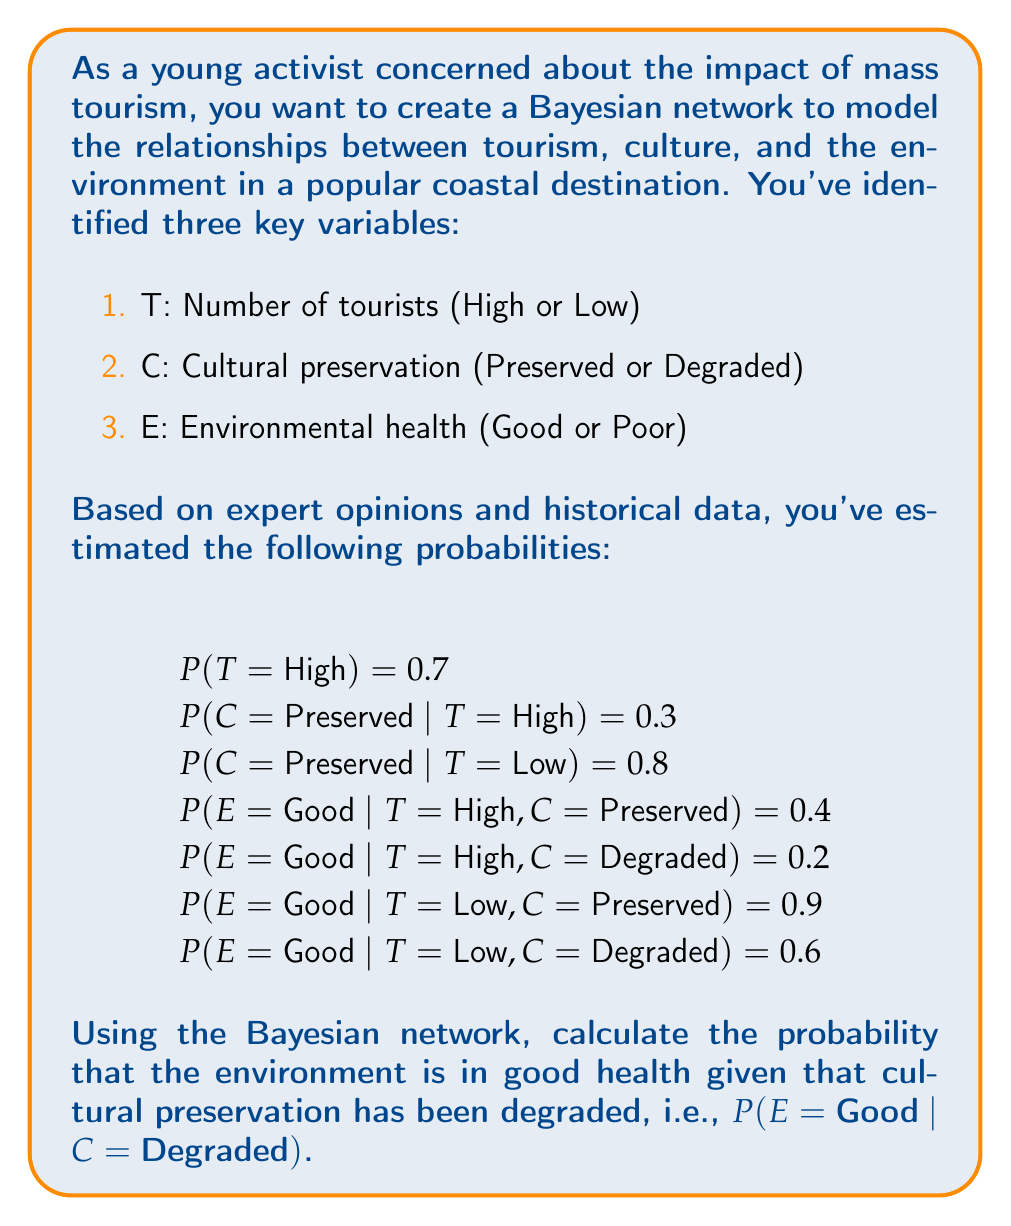Show me your answer to this math problem. To solve this problem, we need to use Bayes' theorem and the law of total probability. Let's break it down step by step:

1) We want to calculate P(E = Good | C = Degraded). Using Bayes' theorem, we can write:

   $$P(E = \text{Good} | C = \text{Degraded}) = \frac{P(C = \text{Degraded} | E = \text{Good}) \cdot P(E = \text{Good})}{P(C = \text{Degraded})}$$

2) We need to calculate each of these terms:

   a) P(C = Degraded | E = Good): We don't have this directly, but we can calculate it later.
   b) P(E = Good): We can calculate this using the law of total probability.
   c) P(C = Degraded): We can calculate this using the law of total probability.

3) Let's start with P(E = Good):

   $$\begin{align}
   P(E = \text{Good}) &= P(E = \text{Good} | T = \text{High}) \cdot P(T = \text{High}) + P(E = \text{Good} | T = \text{Low}) \cdot P(T = \text{Low}) \\
   &= [P(E = \text{Good} | T = \text{High}, C = \text{Preserved}) \cdot P(C = \text{Preserved} | T = \text{High}) + \\
   &\quad P(E = \text{Good} | T = \text{High}, C = \text{Degraded}) \cdot P(C = \text{Degraded} | T = \text{High})] \cdot P(T = \text{High}) + \\
   &\quad [P(E = \text{Good} | T = \text{Low}, C = \text{Preserved}) \cdot P(C = \text{Preserved} | T = \text{Low}) + \\
   &\quad P(E = \text{Good} | T = \text{Low}, C = \text{Degraded}) \cdot P(C = \text{Degraded} | T = \text{Low})] \cdot P(T = \text{Low}) \\
   &= [0.4 \cdot 0.3 + 0.2 \cdot 0.7] \cdot 0.7 + [0.9 \cdot 0.8 + 0.6 \cdot 0.2] \cdot 0.3 \\
   &= 0.224 \cdot 0.7 + 0.84 \cdot 0.3 \\
   &= 0.1568 + 0.252 \\
   &= 0.4088
   \end{align}$$

4) Now, let's calculate P(C = Degraded):

   $$\begin{align}
   P(C = \text{Degraded}) &= P(C = \text{Degraded} | T = \text{High}) \cdot P(T = \text{High}) + P(C = \text{Degraded} | T = \text{Low}) \cdot P(T = \text{Low}) \\
   &= (1 - 0.3) \cdot 0.7 + (1 - 0.8) \cdot 0.3 \\
   &= 0.7 \cdot 0.7 + 0.2 \cdot 0.3 \\
   &= 0.49 + 0.06 \\
   &= 0.55
   \end{align}$$

5) Now we can calculate P(C = Degraded | E = Good) using Bayes' theorem:

   $$\begin{align}
   P(C = \text{Degraded} | E = \text{Good}) &= \frac{P(E = \text{Good} | C = \text{Degraded}) \cdot P(C = \text{Degraded})}{P(E = \text{Good})} \\
   &= \frac{[0.2 \cdot 0.7 + 0.6 \cdot 0.3] \cdot 0.55}{0.4088} \\
   &= \frac{0.14 + 0.18}{0.4088} \cdot 0.55 \\
   &= \frac{0.32 \cdot 0.55}{0.4088} \\
   &= 0.4305
   \end{align}$$

6) Finally, we can calculate P(E = Good | C = Degraded):

   $$\begin{align}
   P(E = \text{Good} | C = \text{Degraded}) &= \frac{P(C = \text{Degraded} | E = \text{Good}) \cdot P(E = \text{Good})}{P(C = \text{Degraded})} \\
   &= \frac{0.4305 \cdot 0.4088}{0.55} \\
   &= 0.3200
   \end{align}$$
Answer: The probability that the environment is in good health given that cultural preservation has been degraded is approximately 0.3200 or 32.00%. 